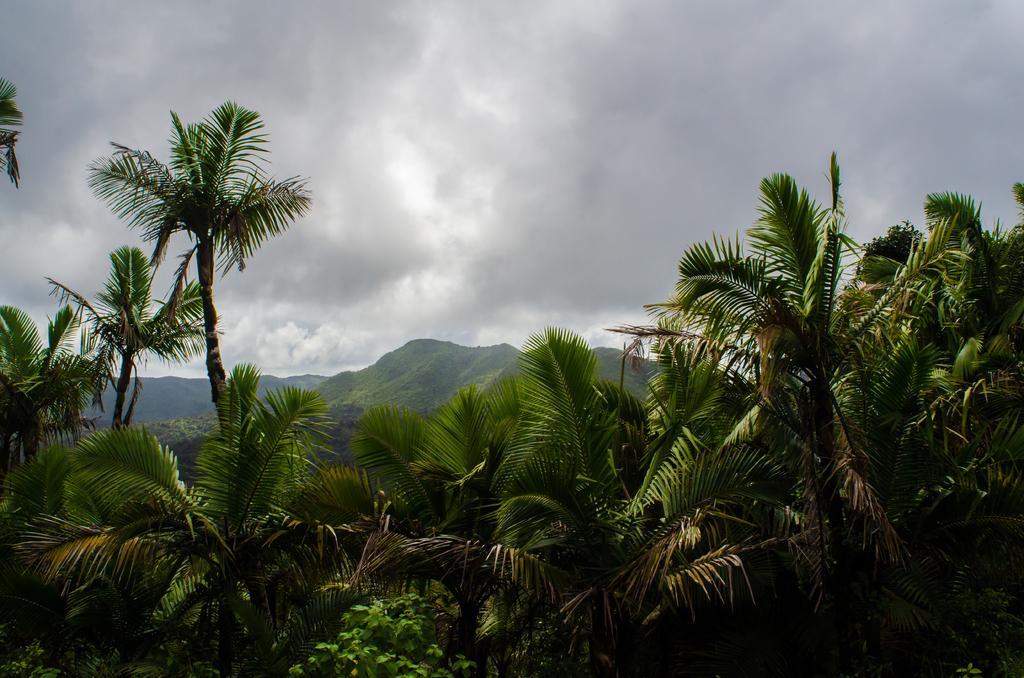In one or two sentences, can you explain what this image depicts? In this image at the bottom there is the hill, trees visible, at the top there is the sky. 